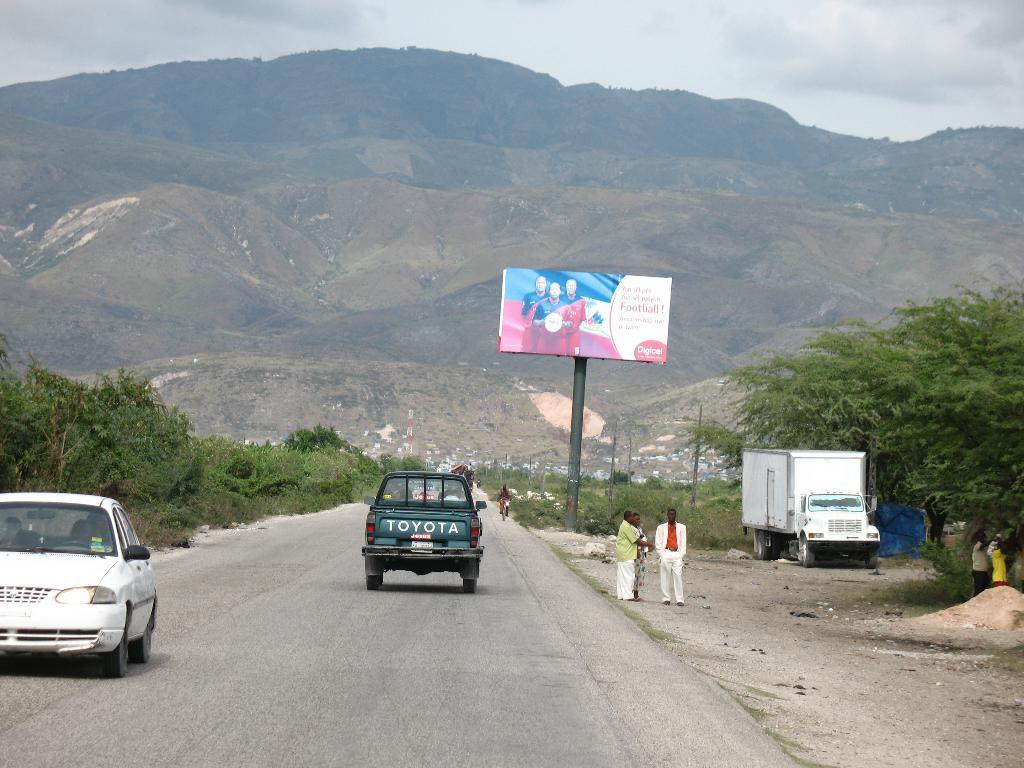Please provide a concise description of this image. In this image in the center there are vehicles moving on the road, there are persons standing. In the background there are trees, there is a board with some text and images on it and there are mountains and the sky is cloudy. 